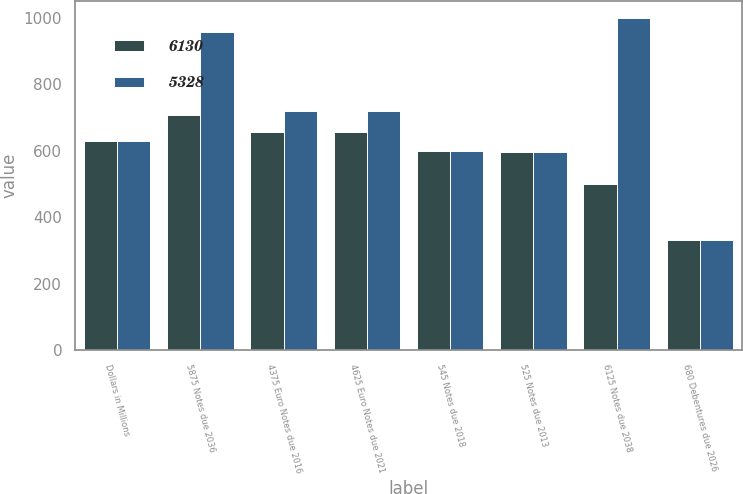<chart> <loc_0><loc_0><loc_500><loc_500><stacked_bar_chart><ecel><fcel>Dollars in Millions<fcel>5875 Notes due 2036<fcel>4375 Euro Notes due 2016<fcel>4625 Euro Notes due 2021<fcel>545 Notes due 2018<fcel>525 Notes due 2013<fcel>6125 Notes due 2038<fcel>680 Debentures due 2026<nl><fcel>6130<fcel>628<fcel>709<fcel>656<fcel>656<fcel>600<fcel>597<fcel>500<fcel>332<nl><fcel>5328<fcel>628<fcel>959<fcel>720<fcel>720<fcel>600<fcel>597<fcel>1000<fcel>332<nl></chart> 